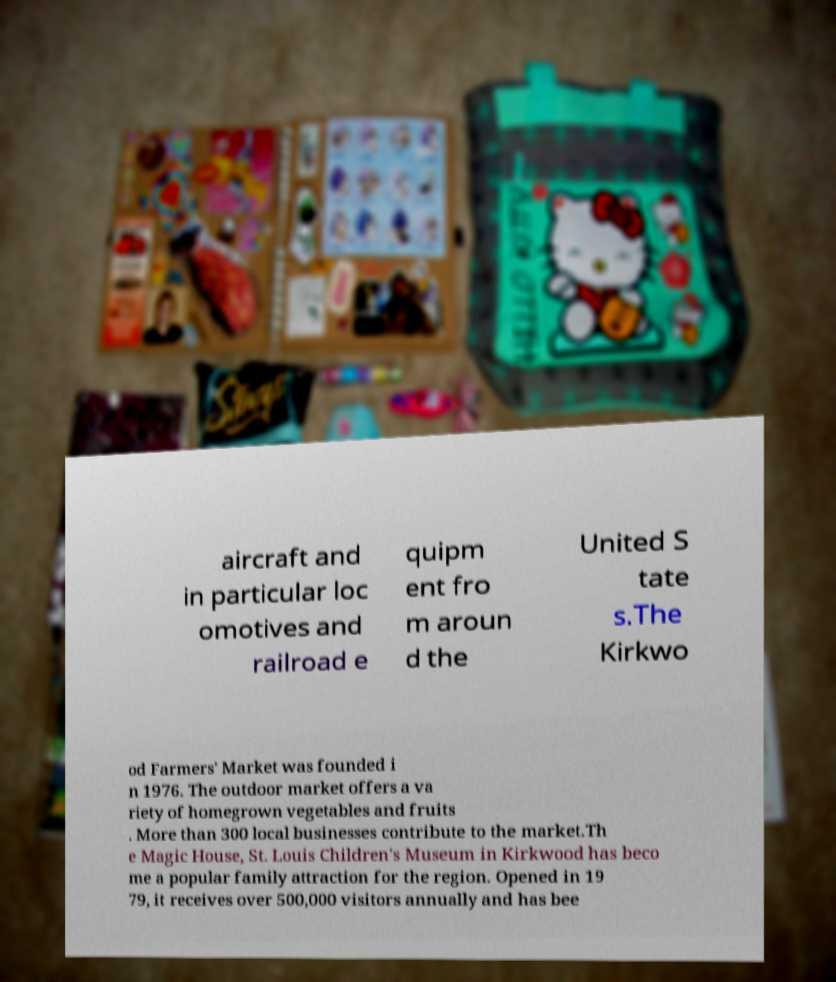Could you assist in decoding the text presented in this image and type it out clearly? aircraft and in particular loc omotives and railroad e quipm ent fro m aroun d the United S tate s.The Kirkwo od Farmers' Market was founded i n 1976. The outdoor market offers a va riety of homegrown vegetables and fruits . More than 300 local businesses contribute to the market.Th e Magic House, St. Louis Children's Museum in Kirkwood has beco me a popular family attraction for the region. Opened in 19 79, it receives over 500,000 visitors annually and has bee 